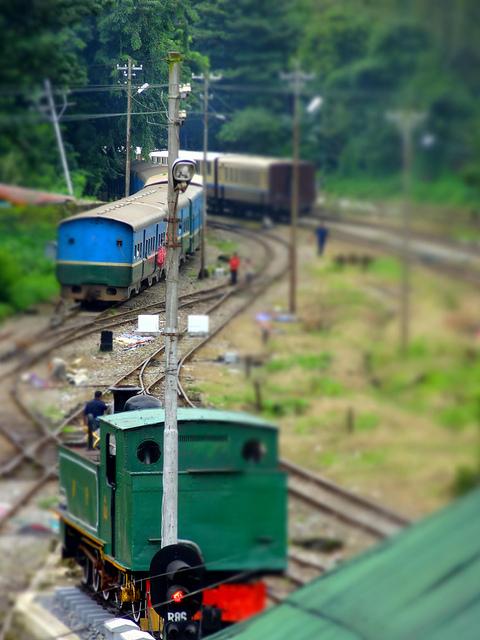What color are the trains?
Be succinct. Green and blue. How many train cars are there?
Short answer required. 5. How many tracks intersect?
Give a very brief answer. 3. 